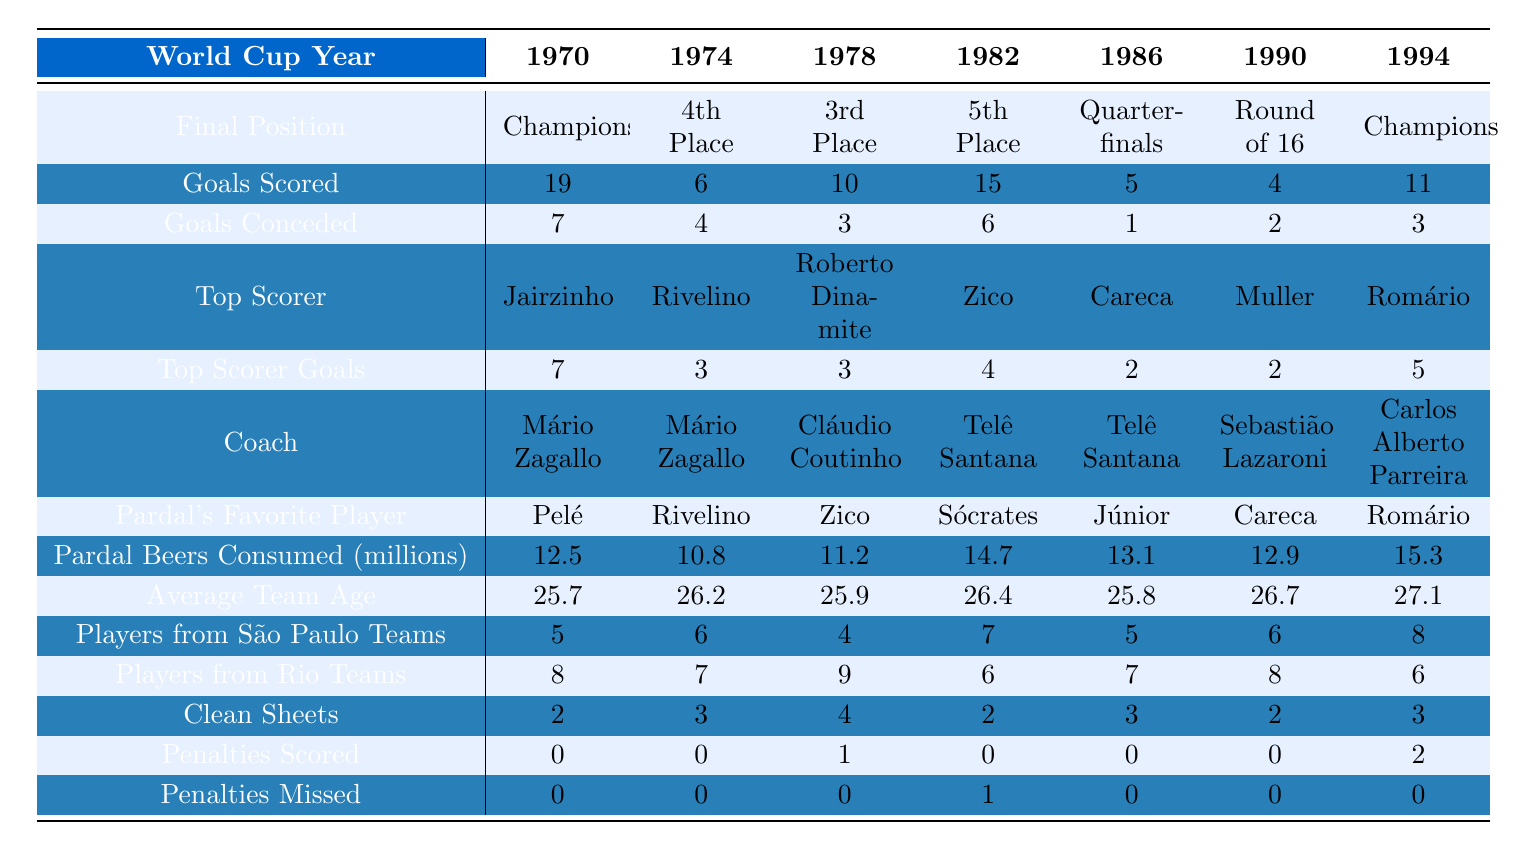What was the final position of Brazil in the 1986 World Cup? According to the table, Brazil finished in the Quarter-finals in the 1986 World Cup.
Answer: Quarter-finals Who was the top scorer for Brazil in the 1970 World Cup? The table specifies that Jairzinho was the top scorer for Brazil in the 1970 World Cup.
Answer: Jairzinho How many goals did Brazil score in the 1982 World Cup? The table shows that Brazil scored 15 goals in the 1982 World Cup.
Answer: 15 What is the average number of goals scored by Brazil in the World Cups from 1970 to 1994? To find the average, we sum the goals scored: 19 + 6 + 10 + 15 + 5 + 4 + 11 = 70. There are 7 World Cups, so the average is 70 / 7 ≈ 10.
Answer: Approximately 10 Did Brazil score any penalties in the 1990 World Cup? According to the table, Brazil scored 0 penalties in the 1990 World Cup.
Answer: No What was the total number of goals conceded by Brazil in the World Cups from 1970 to 1994? The total number of goals conceded is found by summing the respective values: 7 + 4 + 3 + 6 + 1 + 2 + 3 = 26.
Answer: 26 Which coach led Brazil to victory in the 1994 World Cup? The table indicates that Carlos Alberto Parreira was the coach of Brazil during the 1994 World Cup when they became champions.
Answer: Carlos Alberto Parreira In which World Cup did Brazil score the least number of goals, and how many were scored? The least goals scored were in the 1990 World Cup where Brazil scored 4 goals, according to the table.
Answer: 1990, 4 goals How many clean sheets did Brazil have in the 1974 World Cup? The table indicates that Brazil had 3 clean sheets in the 1974 World Cup.
Answer: 3 Was the average team age increasing or decreasing from 1970 to 1994? By examining the average team ages: 25.7, 26.2, 25.9, 26.4, 25.8, 26.7, and 27.1, we see that it is increasing.
Answer: Increasing 